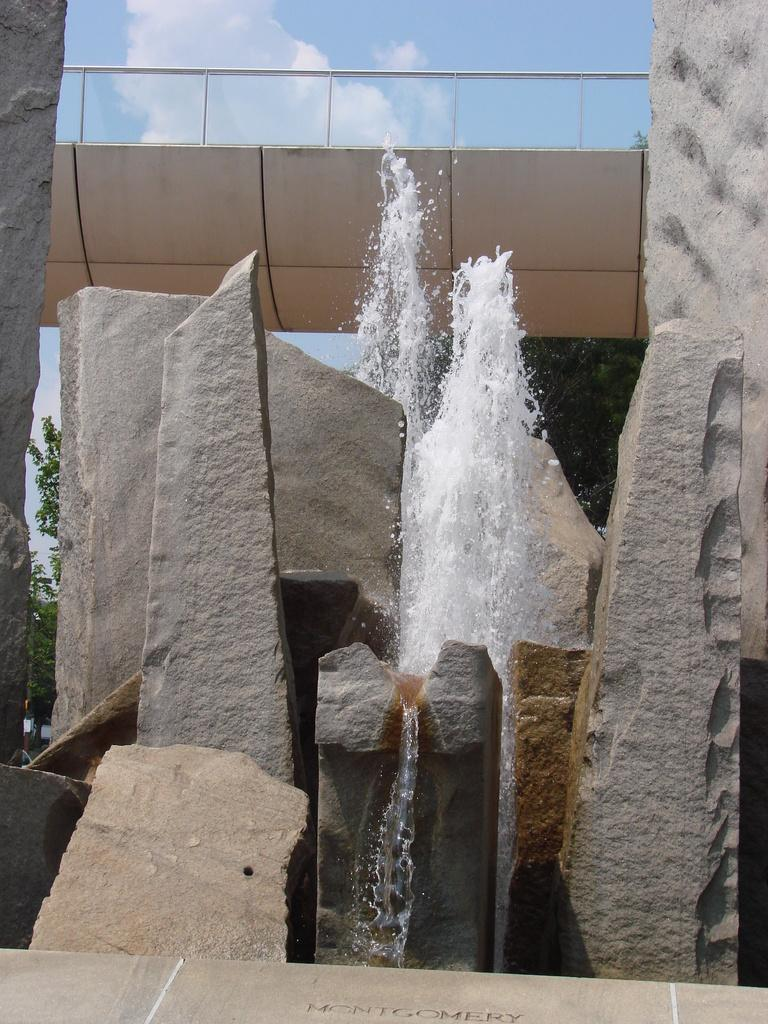What is the primary element visible in the image? There is water in the image. What other objects or features can be seen in the image? There are rocks and trees visible in the image. What can be seen in the background of the image? The sky is visible in the background of the image. What type of nut is being cracked by the group in the image? There is no group or nut present in the image; it features water, rocks, trees, and the sky. 